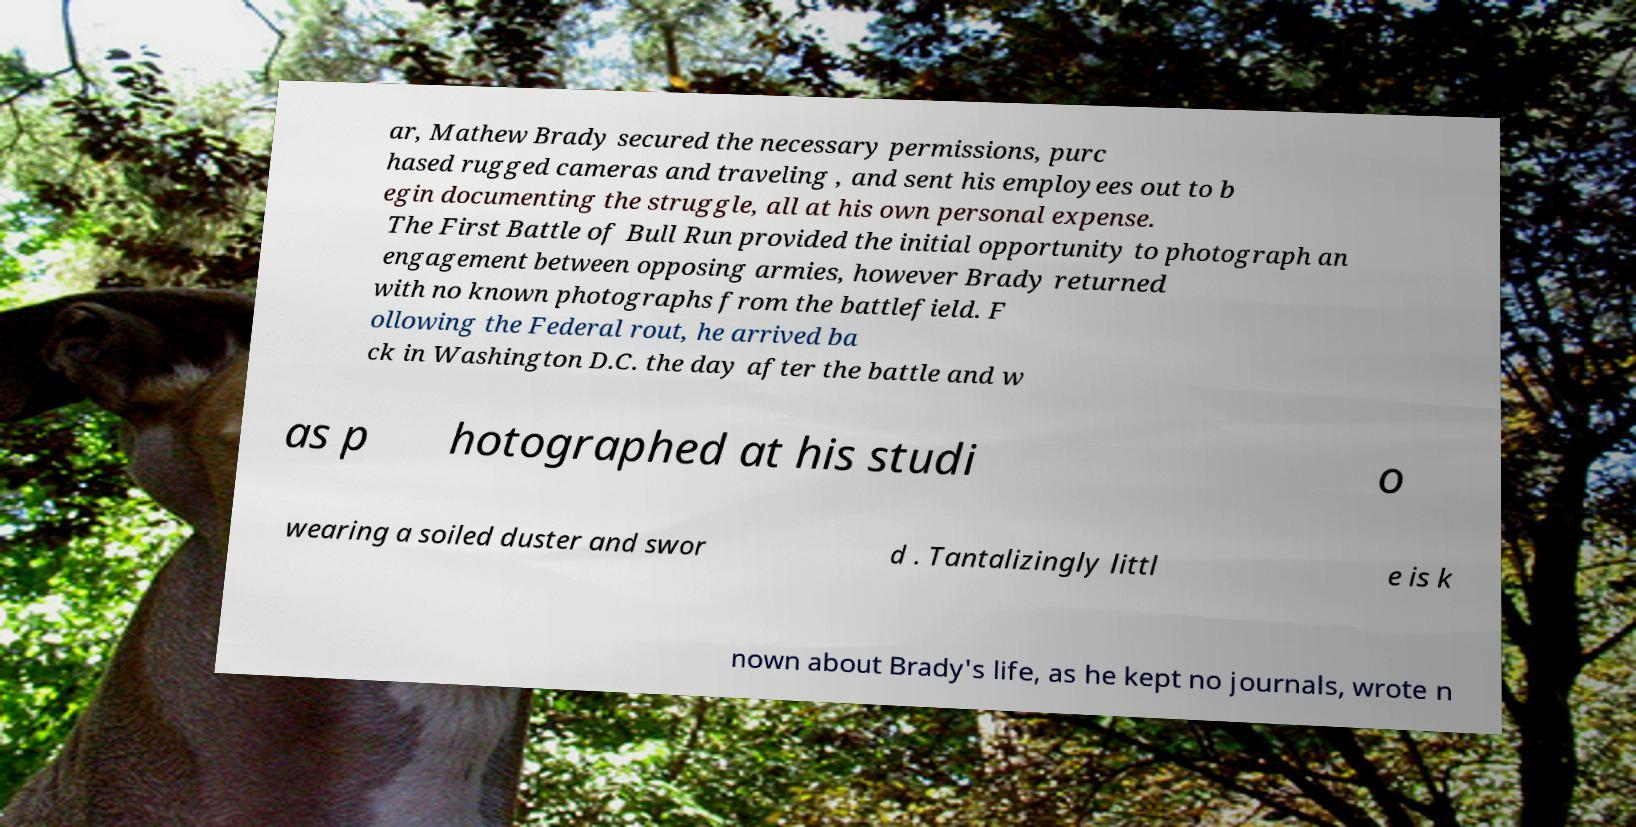Can you accurately transcribe the text from the provided image for me? ar, Mathew Brady secured the necessary permissions, purc hased rugged cameras and traveling , and sent his employees out to b egin documenting the struggle, all at his own personal expense. The First Battle of Bull Run provided the initial opportunity to photograph an engagement between opposing armies, however Brady returned with no known photographs from the battlefield. F ollowing the Federal rout, he arrived ba ck in Washington D.C. the day after the battle and w as p hotographed at his studi o wearing a soiled duster and swor d . Tantalizingly littl e is k nown about Brady's life, as he kept no journals, wrote n 